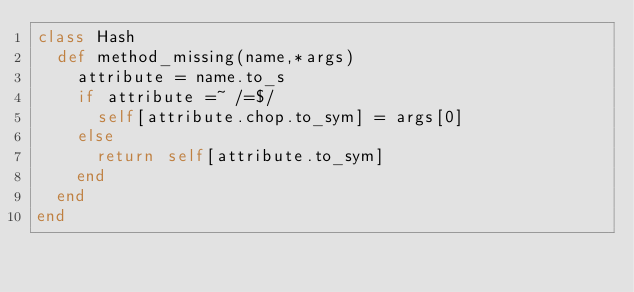<code> <loc_0><loc_0><loc_500><loc_500><_Ruby_>class Hash
  def method_missing(name,*args)
    attribute = name.to_s
    if attribute =~ /=$/
      self[attribute.chop.to_sym] = args[0]
    else
      return self[attribute.to_sym]
    end
  end
end
</code> 